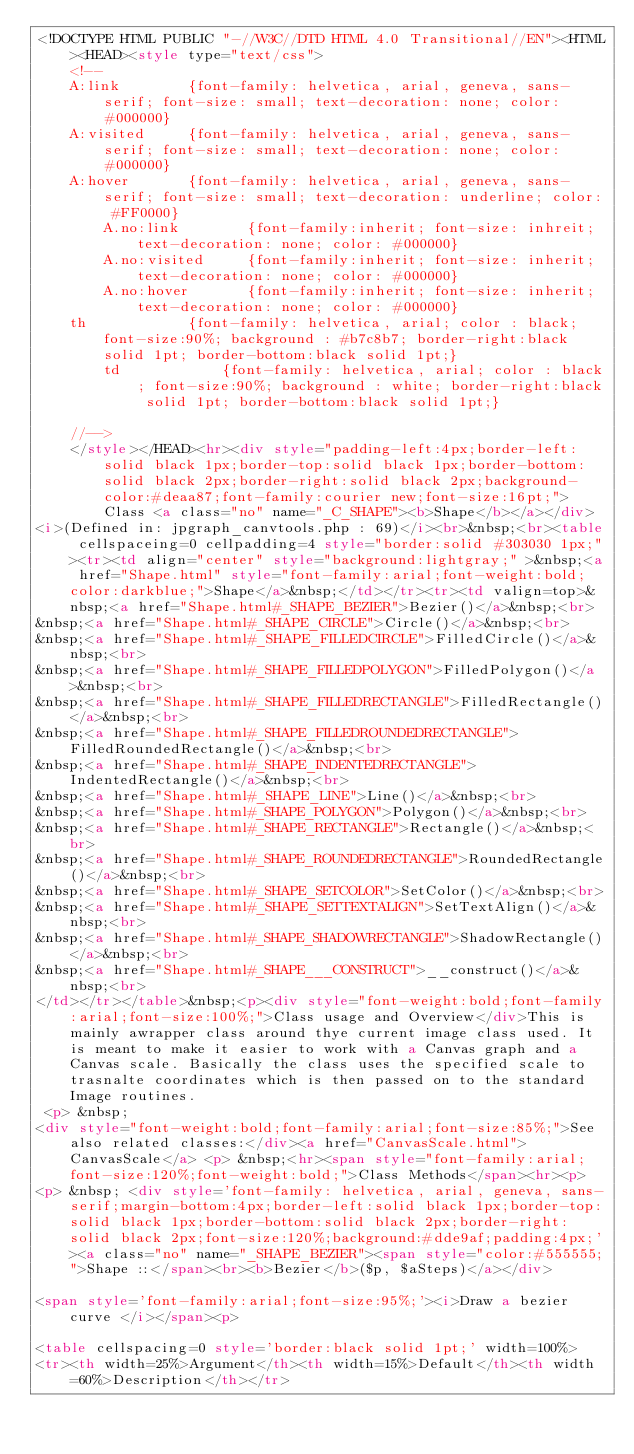<code> <loc_0><loc_0><loc_500><loc_500><_HTML_><!DOCTYPE HTML PUBLIC "-//W3C//DTD HTML 4.0 Transitional//EN"><HTML><HEAD><style type="text/css">
		<!--
		A:link        {font-family: helvetica, arial, geneva, sans-serif; font-size: small; text-decoration: none; color: #000000}
		A:visited     {font-family: helvetica, arial, geneva, sans-serif; font-size: small; text-decoration: none; color: #000000}
		A:hover       {font-family: helvetica, arial, geneva, sans-serif; font-size: small; text-decoration: underline; color: #FF0000}
        A.no:link        {font-family:inherit; font-size: inhreit;text-decoration: none; color: #000000}
        A.no:visited     {font-family:inherit; font-size: inherit;text-decoration: none; color: #000000}
        A.no:hover       {font-family:inherit; font-size: inherit;text-decoration: none; color: #000000}
		th            {font-family: helvetica, arial; color : black; font-size:90%; background : #b7c8b7; border-right:black solid 1pt; border-bottom:black solid 1pt;}
        td            {font-family: helvetica, arial; color : black; font-size:90%; background : white; border-right:black solid 1pt; border-bottom:black solid 1pt;}

		//-->
		</style></HEAD><hr><div style="padding-left:4px;border-left:solid black 1px;border-top:solid black 1px;border-bottom:solid black 2px;border-right:solid black 2px;background-color:#deaa87;font-family:courier new;font-size:16pt;">Class <a class="no" name="_C_SHAPE"><b>Shape</b></a></div>
<i>(Defined in: jpgraph_canvtools.php : 69)</i><br>&nbsp;<br><table cellspaceing=0 cellpadding=4 style="border:solid #303030 1px;"><tr><td align="center" style="background:lightgray;" >&nbsp;<a href="Shape.html" style="font-family:arial;font-weight:bold;color:darkblue;">Shape</a>&nbsp;</td></tr><tr><td valign=top>&nbsp;<a href="Shape.html#_SHAPE_BEZIER">Bezier()</a>&nbsp;<br>
&nbsp;<a href="Shape.html#_SHAPE_CIRCLE">Circle()</a>&nbsp;<br>
&nbsp;<a href="Shape.html#_SHAPE_FILLEDCIRCLE">FilledCircle()</a>&nbsp;<br>
&nbsp;<a href="Shape.html#_SHAPE_FILLEDPOLYGON">FilledPolygon()</a>&nbsp;<br>
&nbsp;<a href="Shape.html#_SHAPE_FILLEDRECTANGLE">FilledRectangle()</a>&nbsp;<br>
&nbsp;<a href="Shape.html#_SHAPE_FILLEDROUNDEDRECTANGLE">FilledRoundedRectangle()</a>&nbsp;<br>
&nbsp;<a href="Shape.html#_SHAPE_INDENTEDRECTANGLE">IndentedRectangle()</a>&nbsp;<br>
&nbsp;<a href="Shape.html#_SHAPE_LINE">Line()</a>&nbsp;<br>
&nbsp;<a href="Shape.html#_SHAPE_POLYGON">Polygon()</a>&nbsp;<br>
&nbsp;<a href="Shape.html#_SHAPE_RECTANGLE">Rectangle()</a>&nbsp;<br>
&nbsp;<a href="Shape.html#_SHAPE_ROUNDEDRECTANGLE">RoundedRectangle()</a>&nbsp;<br>
&nbsp;<a href="Shape.html#_SHAPE_SETCOLOR">SetColor()</a>&nbsp;<br>
&nbsp;<a href="Shape.html#_SHAPE_SETTEXTALIGN">SetTextAlign()</a>&nbsp;<br>
&nbsp;<a href="Shape.html#_SHAPE_SHADOWRECTANGLE">ShadowRectangle()</a>&nbsp;<br>
&nbsp;<a href="Shape.html#_SHAPE___CONSTRUCT">__construct()</a>&nbsp;<br>
</td></tr></table>&nbsp;<p><div style="font-weight:bold;font-family:arial;font-size:100%;">Class usage and Overview</div>This is mainly awrapper class around thye current image class used. It is meant to make it easier to work with a Canvas graph and a Canvas scale. Basically the class uses the specified scale to trasnalte coordinates which is then passed on to the standard Image routines.
 <p> &nbsp;
<div style="font-weight:bold;font-family:arial;font-size:85%;">See also related classes:</div><a href="CanvasScale.html">CanvasScale</a> <p> &nbsp;<hr><span style="font-family:arial;font-size:120%;font-weight:bold;">Class Methods</span><hr><p>
<p> &nbsp; <div style='font-family: helvetica, arial, geneva, sans-serif;margin-bottom:4px;border-left:solid black 1px;border-top:solid black 1px;border-bottom:solid black 2px;border-right:solid black 2px;font-size:120%;background:#dde9af;padding:4px;'><a class="no" name="_SHAPE_BEZIER"><span style="color:#555555;">Shape ::</span><br><b>Bezier</b>($p, $aSteps)</a></div>

<span style='font-family:arial;font-size:95%;'><i>Draw a bezier curve </i></span><p>

<table cellspacing=0 style='border:black solid 1pt;' width=100%>
<tr><th width=25%>Argument</th><th width=15%>Default</th><th width=60%>Description</th></tr></code> 